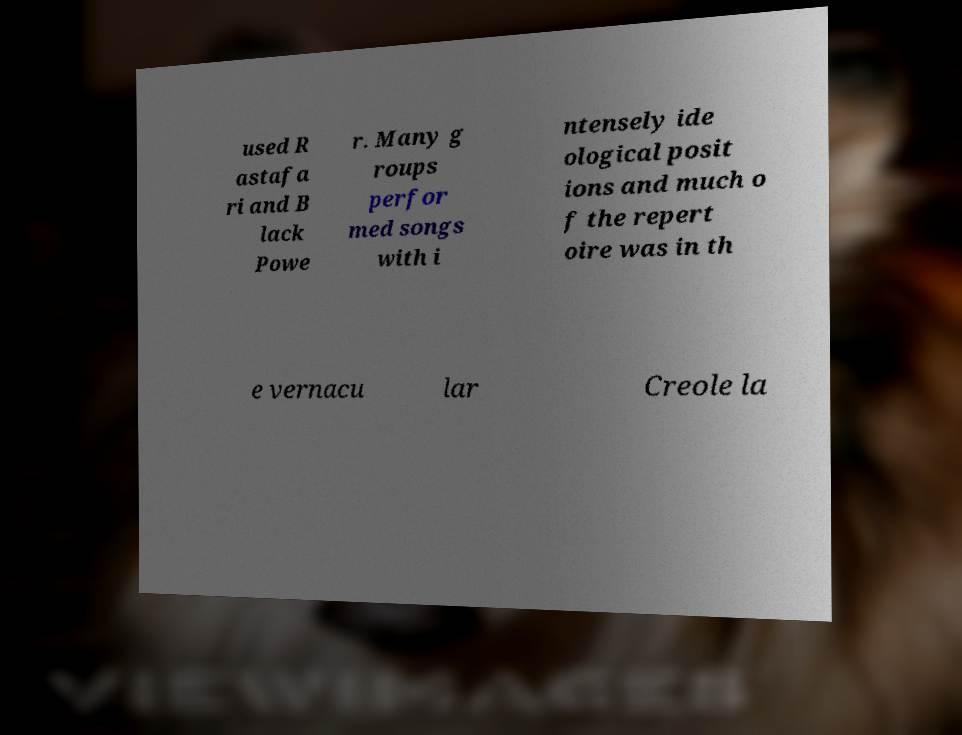Please identify and transcribe the text found in this image. used R astafa ri and B lack Powe r. Many g roups perfor med songs with i ntensely ide ological posit ions and much o f the repert oire was in th e vernacu lar Creole la 